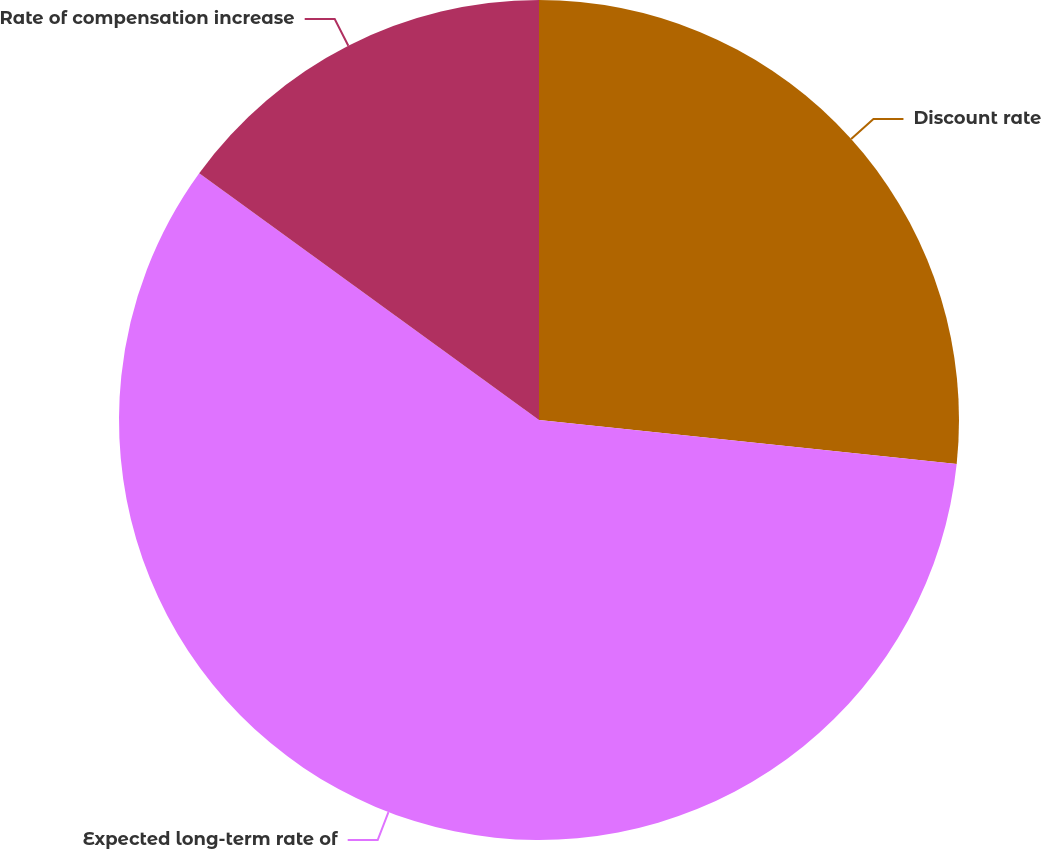Convert chart to OTSL. <chart><loc_0><loc_0><loc_500><loc_500><pie_chart><fcel>Discount rate<fcel>Expected long-term rate of<fcel>Rate of compensation increase<nl><fcel>26.67%<fcel>58.33%<fcel>15.0%<nl></chart> 